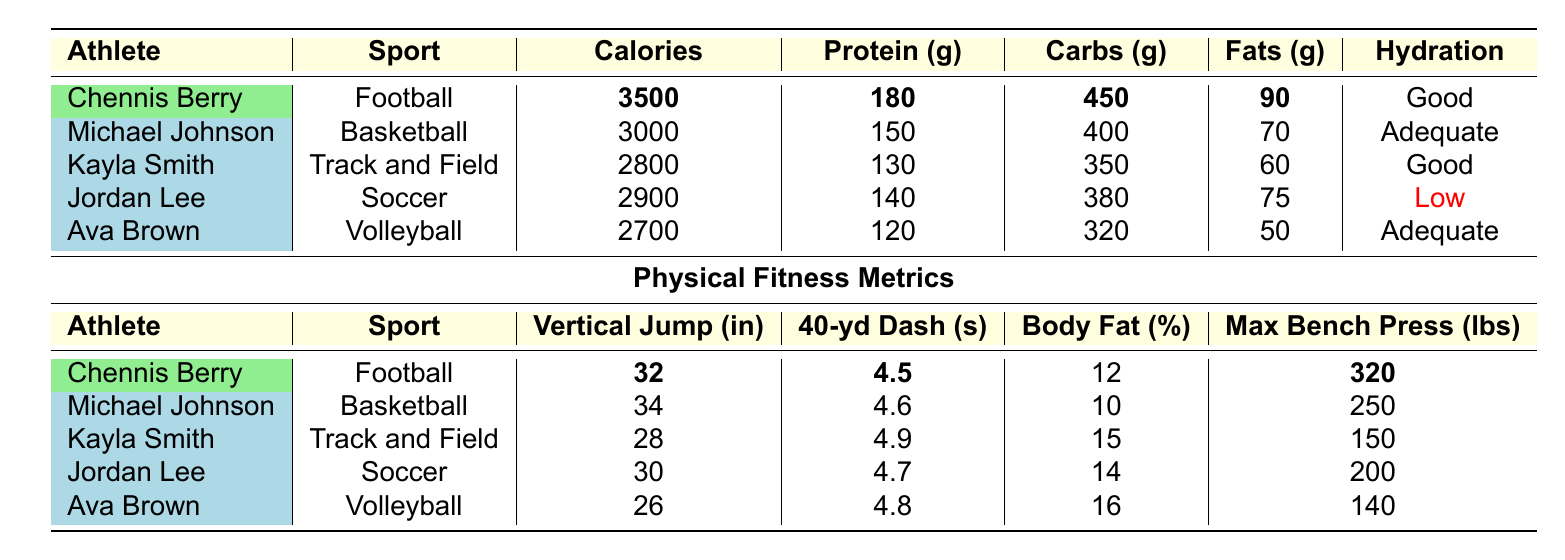What is the hydration status of Chennis Berry? The table shows that Chennis Berry's hydration status is listed under the "Hydration" column, and it states "Good."
Answer: Good Which athlete has the highest protein intake? By comparing the "Protein (g)" column, Chennis Berry has the highest protein intake at 180 grams, more than any other athlete.
Answer: Chennis Berry What percentage of body fat does Ava Brown have? The table indicates that Ava Brown's body fat percentage is listed under the "Body Fat (%)" column, which is 16%.
Answer: 16 What is the total calories intake for all athletes combined? The total is calculated by adding each athlete's calories intake: 3500 + 3000 + 2800 + 2900 + 2700 = 14900.
Answer: 14900 Which athlete has the best 40-yard dash time? By comparing the "40-yd Dash (s)" times, Chennis Berry has the best time at 4.5 seconds, which is lower than the times listed for the other athletes.
Answer: Chennis Berry Is Michael Johnson's max bench press higher than Kayla Smith's? The max bench press for Michael Johnson is 250 pounds, while Kayla Smith's is 150 pounds, making Michael's higher.
Answer: Yes What is the difference in vertical jump between Chennis Berry and Ava Brown? Chennis Berry has a vertical jump of 32 inches, while Ava Brown has 26 inches. The difference is 32 - 26 = 6 inches.
Answer: 6 inches What is the average carbohydrates intake for the athletes? To find the average, sum the carbohydrates intake: 450 + 400 + 350 + 380 + 320 = 1900. Then divide by 5 (the number of athletes): 1900 / 5 = 380.
Answer: 380 How many athletes are listed with a hydration status of "Good"? The table indicates that Chennis Berry and Kayla Smith both have a hydration status of "Good," making it two athletes.
Answer: 2 Who has the lowest maximum bench press, and what is that value? By reviewing the "Max Bench Press (lbs)" column, Ava Brown has the lowest bench press at 140 pounds.
Answer: Ava Brown, 140 lbs 